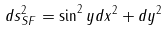Convert formula to latex. <formula><loc_0><loc_0><loc_500><loc_500>d s _ { S F } ^ { 2 } = \sin ^ { 2 } y d x ^ { 2 } + d y ^ { 2 }</formula> 